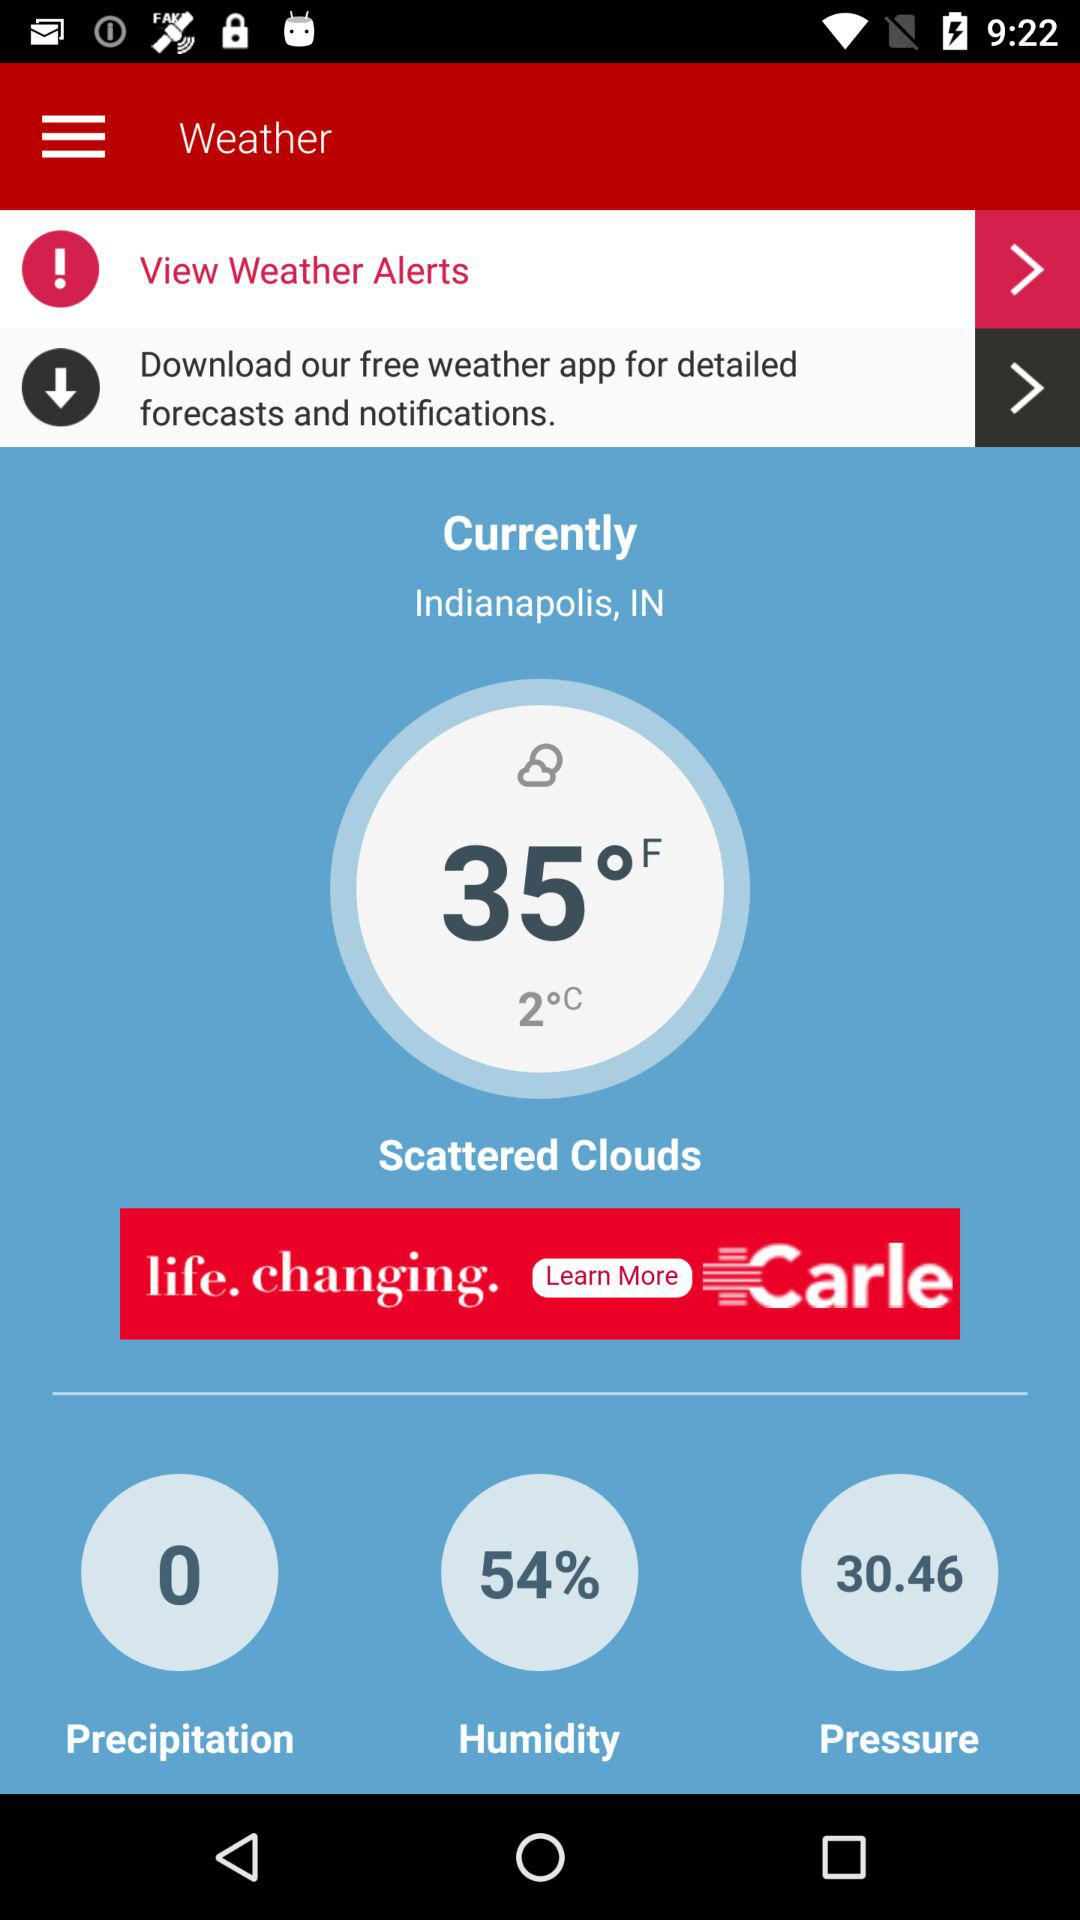How is the weather? The weather is like scattered clouds. 